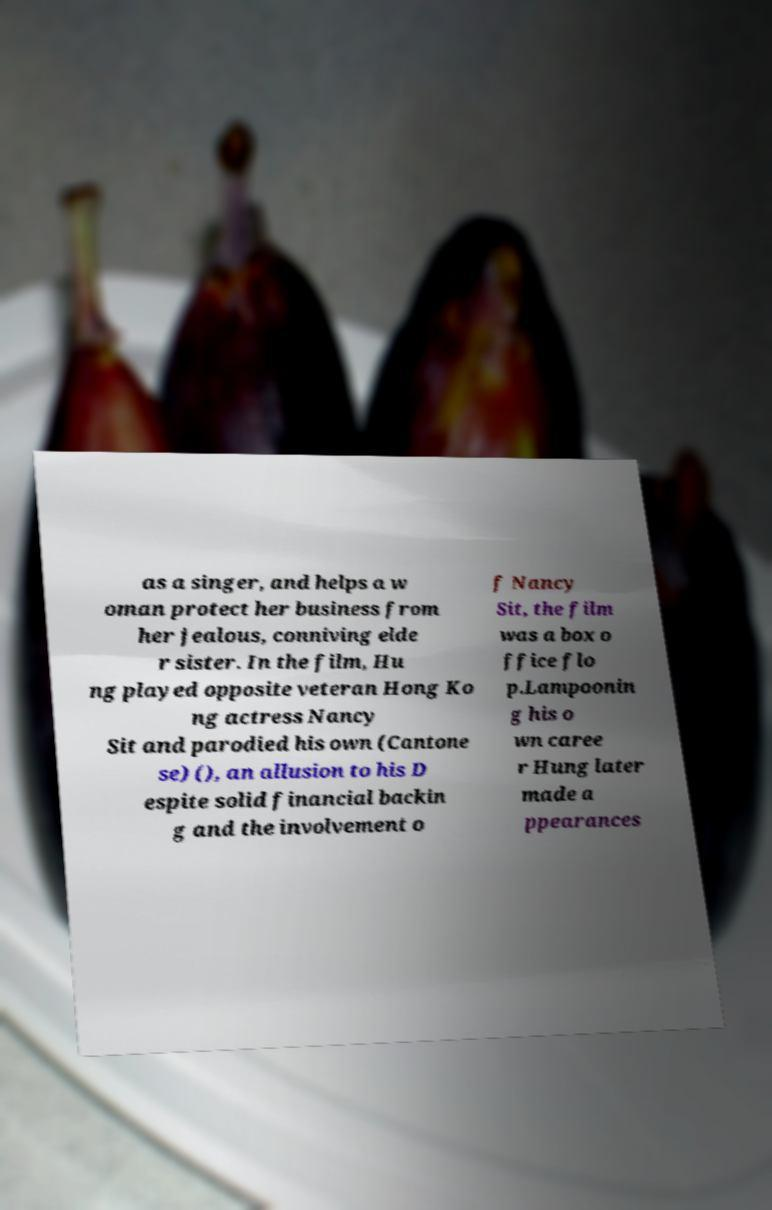What messages or text are displayed in this image? I need them in a readable, typed format. as a singer, and helps a w oman protect her business from her jealous, conniving elde r sister. In the film, Hu ng played opposite veteran Hong Ko ng actress Nancy Sit and parodied his own (Cantone se) (), an allusion to his D espite solid financial backin g and the involvement o f Nancy Sit, the film was a box o ffice flo p.Lampoonin g his o wn caree r Hung later made a ppearances 